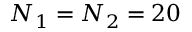<formula> <loc_0><loc_0><loc_500><loc_500>N _ { 1 } = N _ { 2 } = 2 0</formula> 